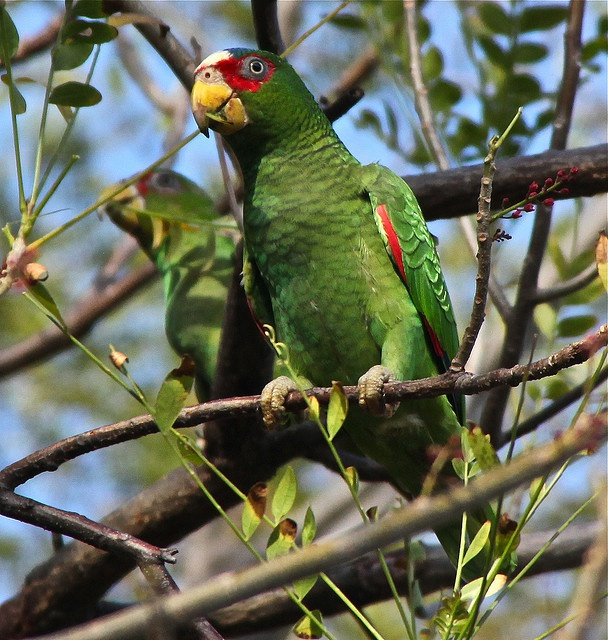Describe the objects in this image and their specific colors. I can see bird in gray, darkgreen, black, and olive tones and bird in gray, black, darkgreen, and olive tones in this image. 